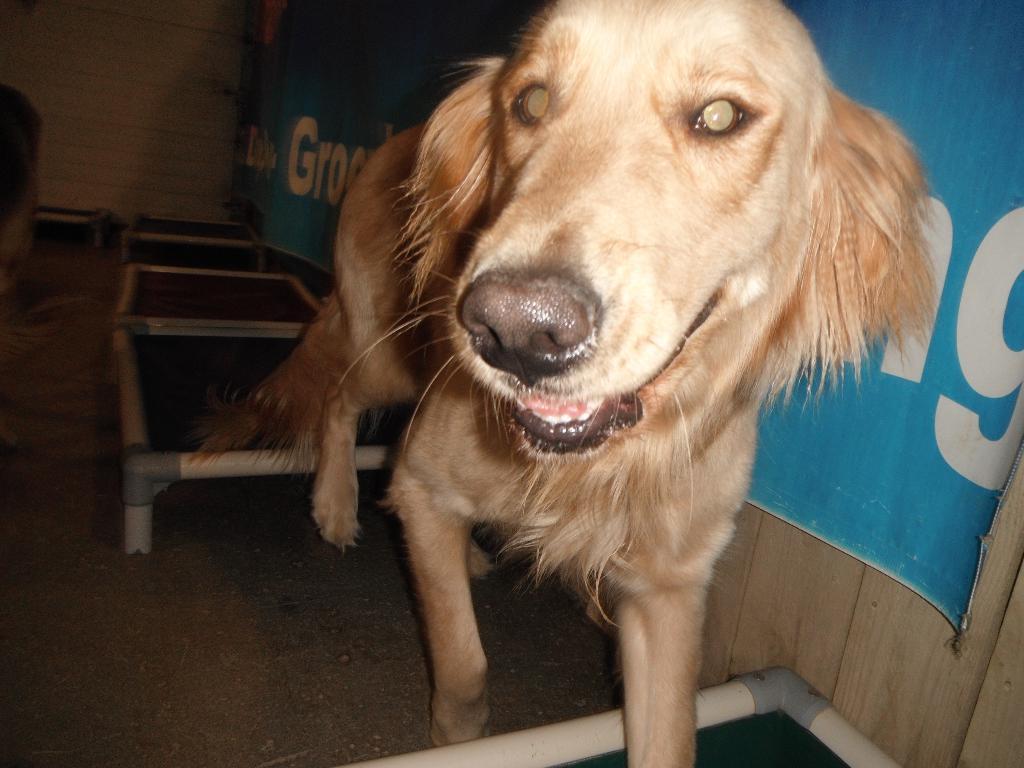How would you summarize this image in a sentence or two? In this picture, we can see a dog, and we can see the ground with objects on it, we can see the wall, poster with some text on it. 